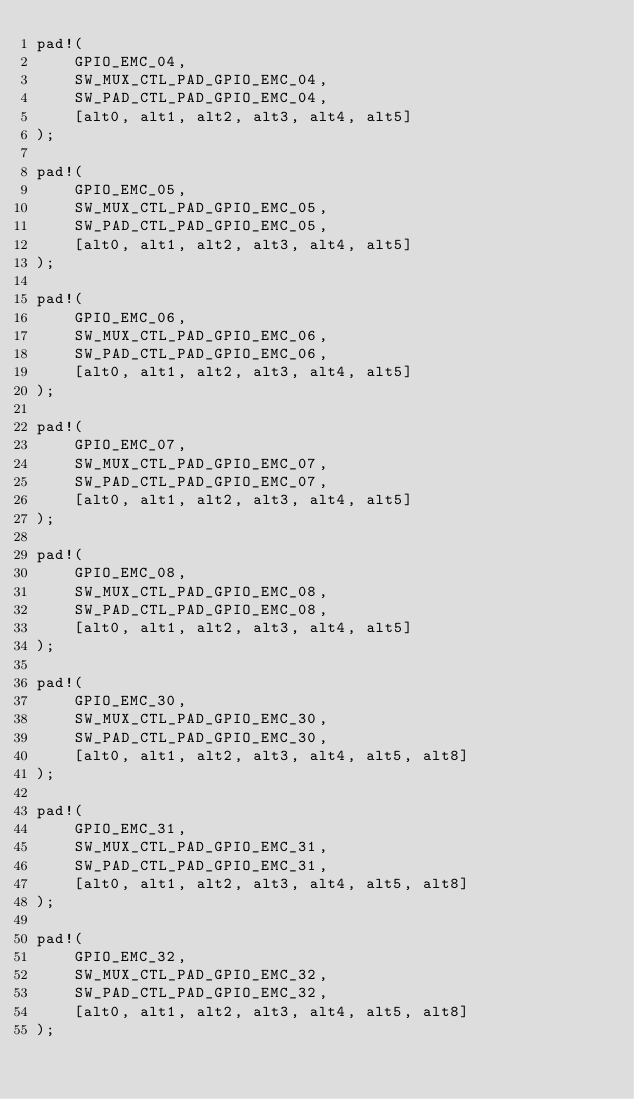Convert code to text. <code><loc_0><loc_0><loc_500><loc_500><_Rust_>pad!(
    GPIO_EMC_04,
    SW_MUX_CTL_PAD_GPIO_EMC_04,
    SW_PAD_CTL_PAD_GPIO_EMC_04,
    [alt0, alt1, alt2, alt3, alt4, alt5]
);

pad!(
    GPIO_EMC_05,
    SW_MUX_CTL_PAD_GPIO_EMC_05,
    SW_PAD_CTL_PAD_GPIO_EMC_05,
    [alt0, alt1, alt2, alt3, alt4, alt5]
);

pad!(
    GPIO_EMC_06,
    SW_MUX_CTL_PAD_GPIO_EMC_06,
    SW_PAD_CTL_PAD_GPIO_EMC_06,
    [alt0, alt1, alt2, alt3, alt4, alt5]
);

pad!(
    GPIO_EMC_07,
    SW_MUX_CTL_PAD_GPIO_EMC_07,
    SW_PAD_CTL_PAD_GPIO_EMC_07,
    [alt0, alt1, alt2, alt3, alt4, alt5]
);

pad!(
    GPIO_EMC_08,
    SW_MUX_CTL_PAD_GPIO_EMC_08,
    SW_PAD_CTL_PAD_GPIO_EMC_08,
    [alt0, alt1, alt2, alt3, alt4, alt5]
);

pad!(
    GPIO_EMC_30,
    SW_MUX_CTL_PAD_GPIO_EMC_30,
    SW_PAD_CTL_PAD_GPIO_EMC_30,
    [alt0, alt1, alt2, alt3, alt4, alt5, alt8]
);

pad!(
    GPIO_EMC_31,
    SW_MUX_CTL_PAD_GPIO_EMC_31,
    SW_PAD_CTL_PAD_GPIO_EMC_31,
    [alt0, alt1, alt2, alt3, alt4, alt5, alt8]
);

pad!(
    GPIO_EMC_32,
    SW_MUX_CTL_PAD_GPIO_EMC_32,
    SW_PAD_CTL_PAD_GPIO_EMC_32,
    [alt0, alt1, alt2, alt3, alt4, alt5, alt8]
);
</code> 